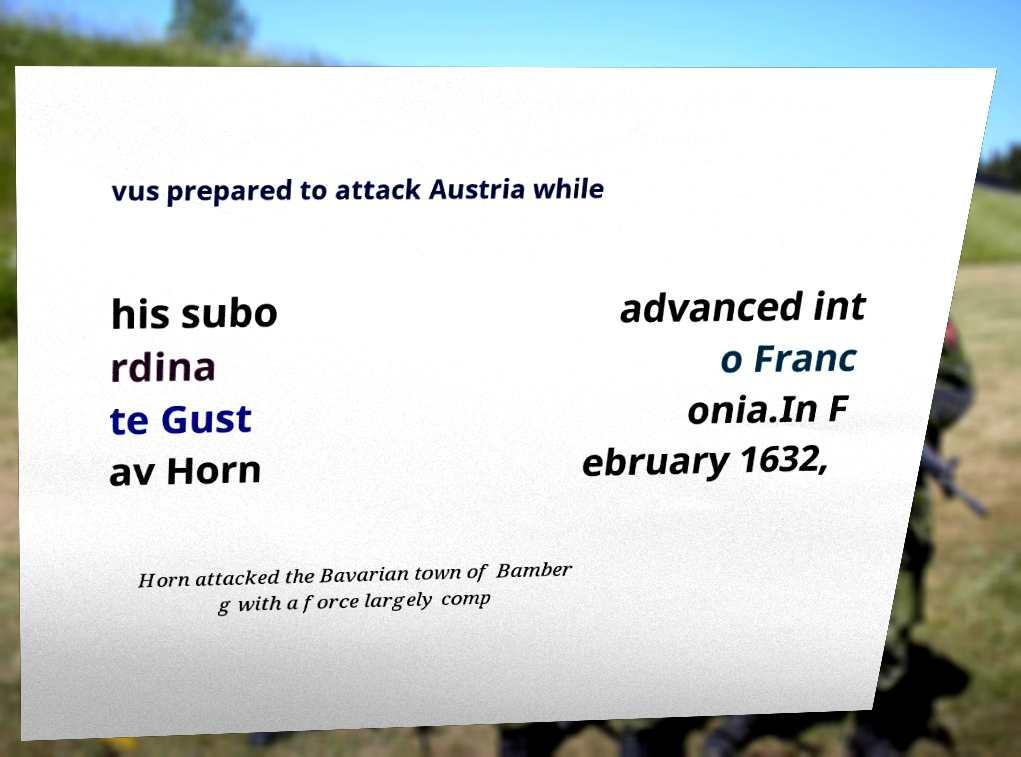Could you extract and type out the text from this image? vus prepared to attack Austria while his subo rdina te Gust av Horn advanced int o Franc onia.In F ebruary 1632, Horn attacked the Bavarian town of Bamber g with a force largely comp 